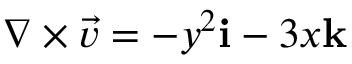Convert formula to latex. <formula><loc_0><loc_0><loc_500><loc_500>\nabla \times { \vec { v } } = - y ^ { 2 } i - 3 x k</formula> 